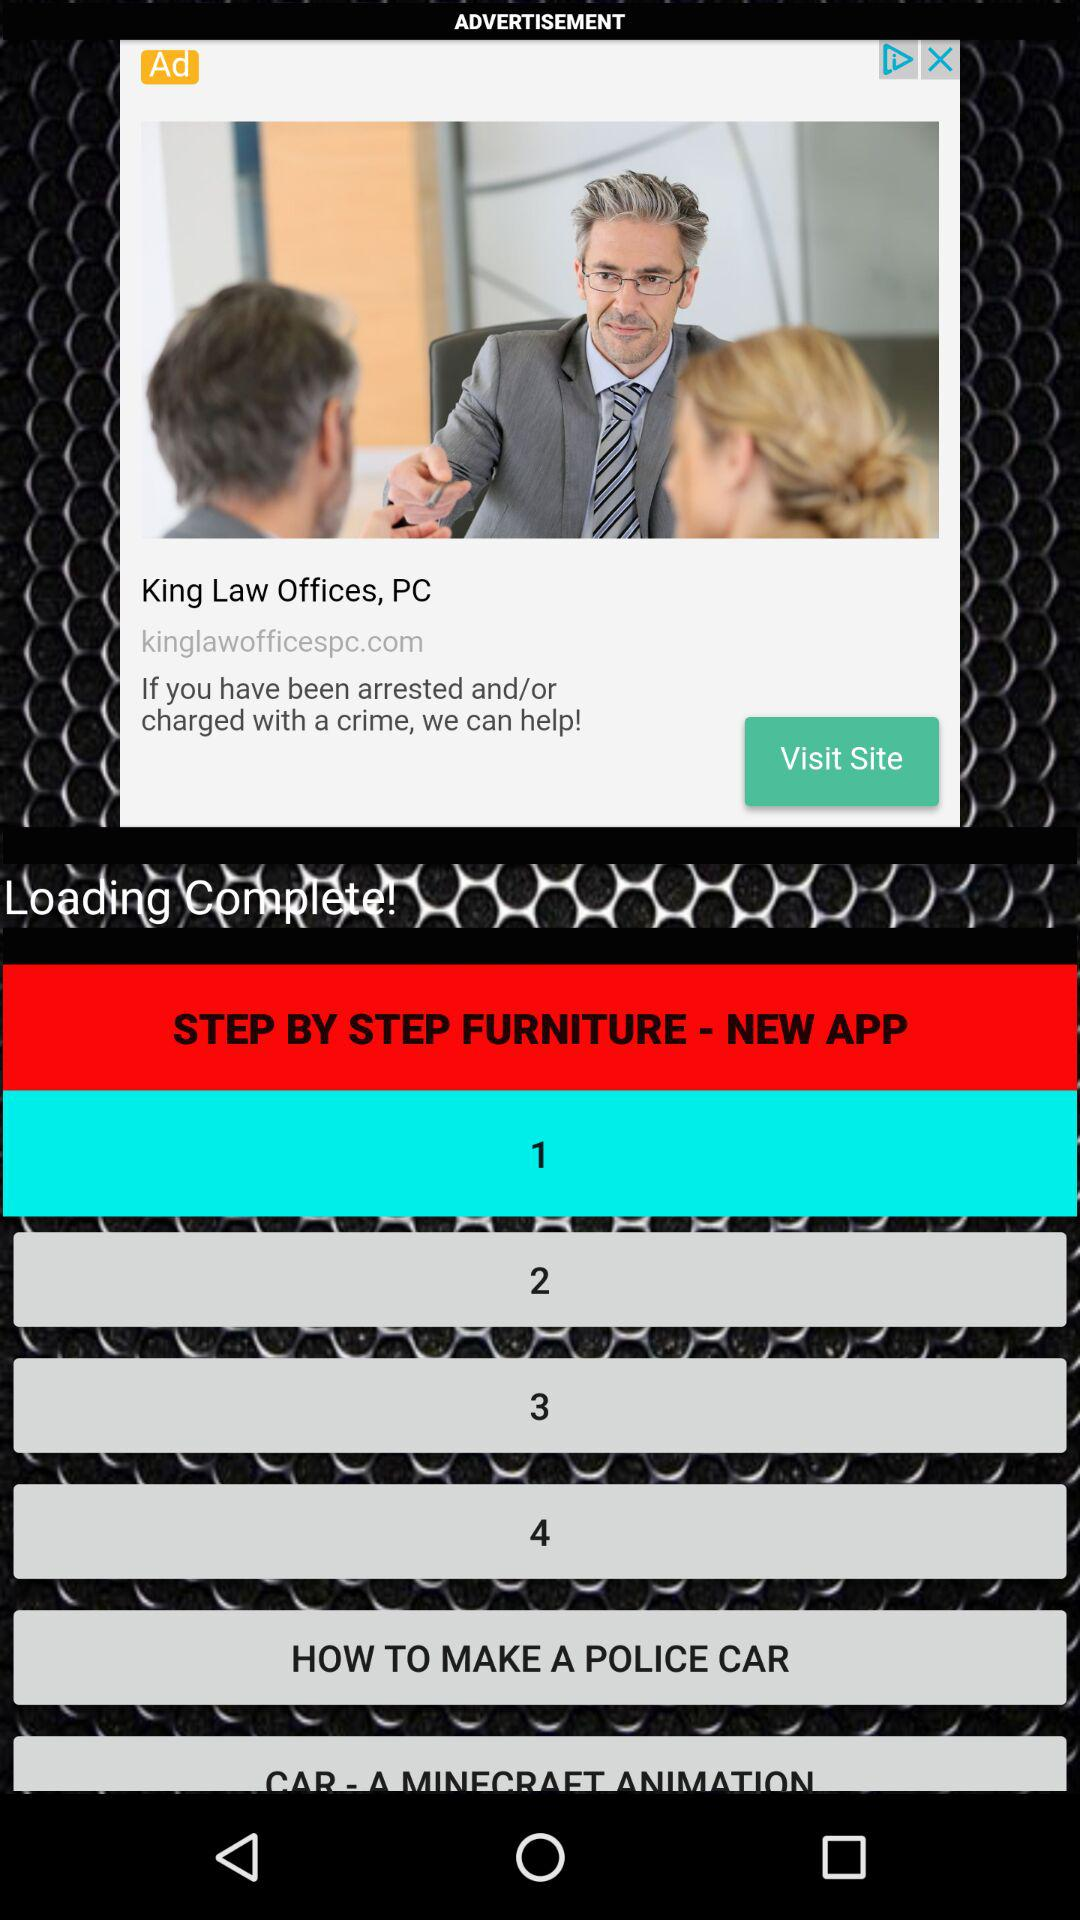What's the number of steps?
When the provided information is insufficient, respond with <no answer>. <no answer> 